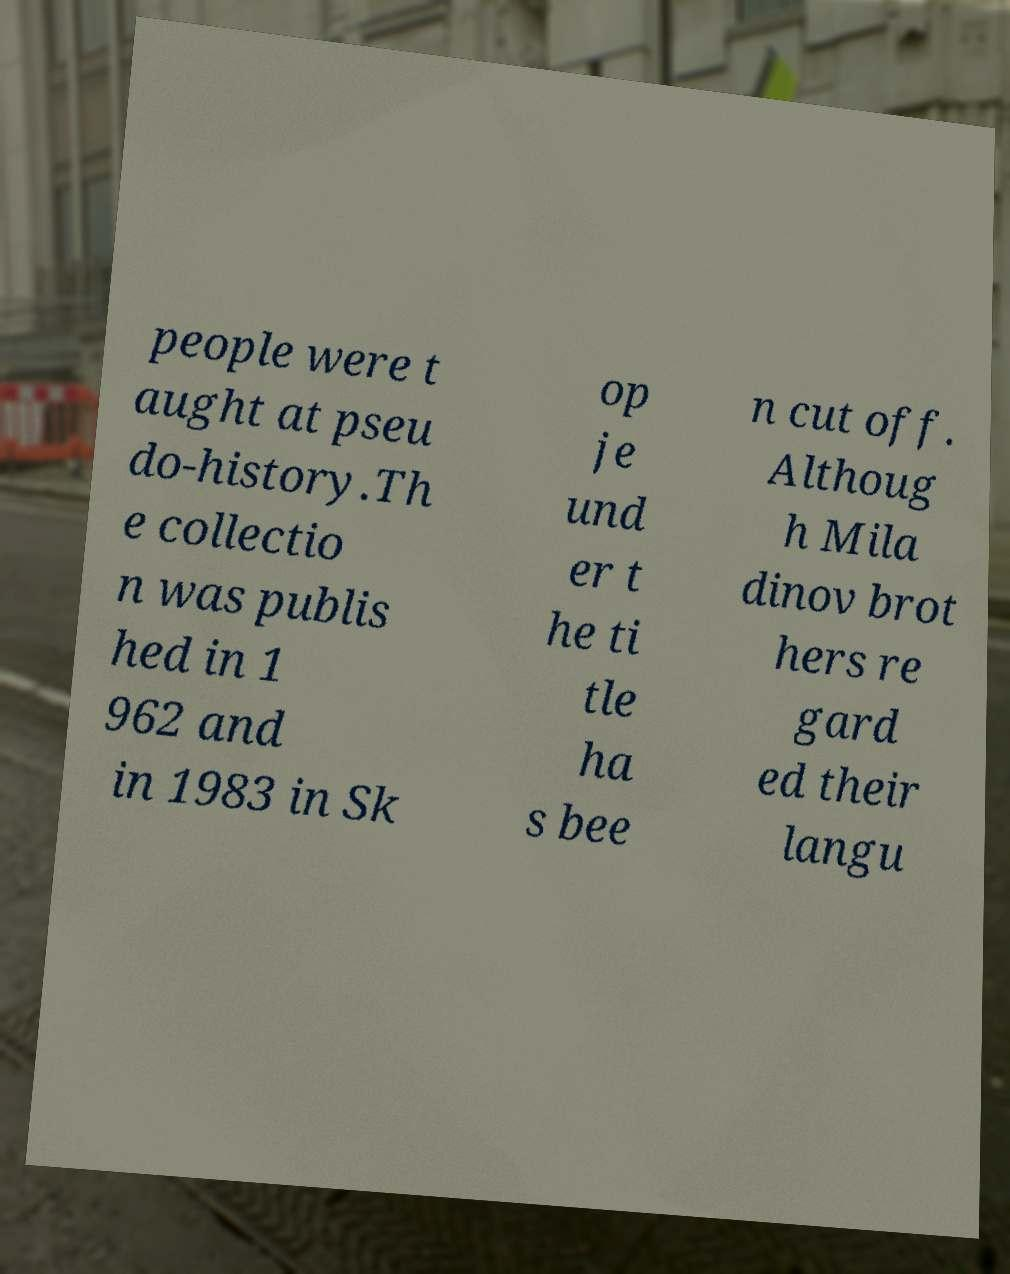Please identify and transcribe the text found in this image. people were t aught at pseu do-history.Th e collectio n was publis hed in 1 962 and in 1983 in Sk op je und er t he ti tle ha s bee n cut off. Althoug h Mila dinov brot hers re gard ed their langu 